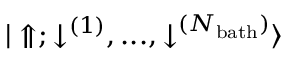<formula> <loc_0><loc_0><loc_500><loc_500>{ | \Uparrow ; \downarrow ^ { ( 1 ) } , \dots , \downarrow ^ { ( N _ { b a t h } ) } \rangle }</formula> 